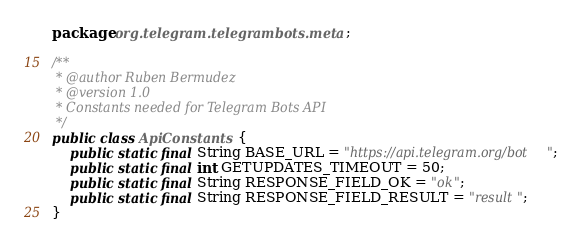Convert code to text. <code><loc_0><loc_0><loc_500><loc_500><_Java_>package org.telegram.telegrambots.meta;

/**
 * @author Ruben Bermudez
 * @version 1.0
 * Constants needed for Telegram Bots API
 */
public class ApiConstants {
    public static final String BASE_URL = "https://api.telegram.org/bot";
    public static final int GETUPDATES_TIMEOUT = 50;
    public static final String RESPONSE_FIELD_OK = "ok";
    public static final String RESPONSE_FIELD_RESULT = "result";
}
</code> 